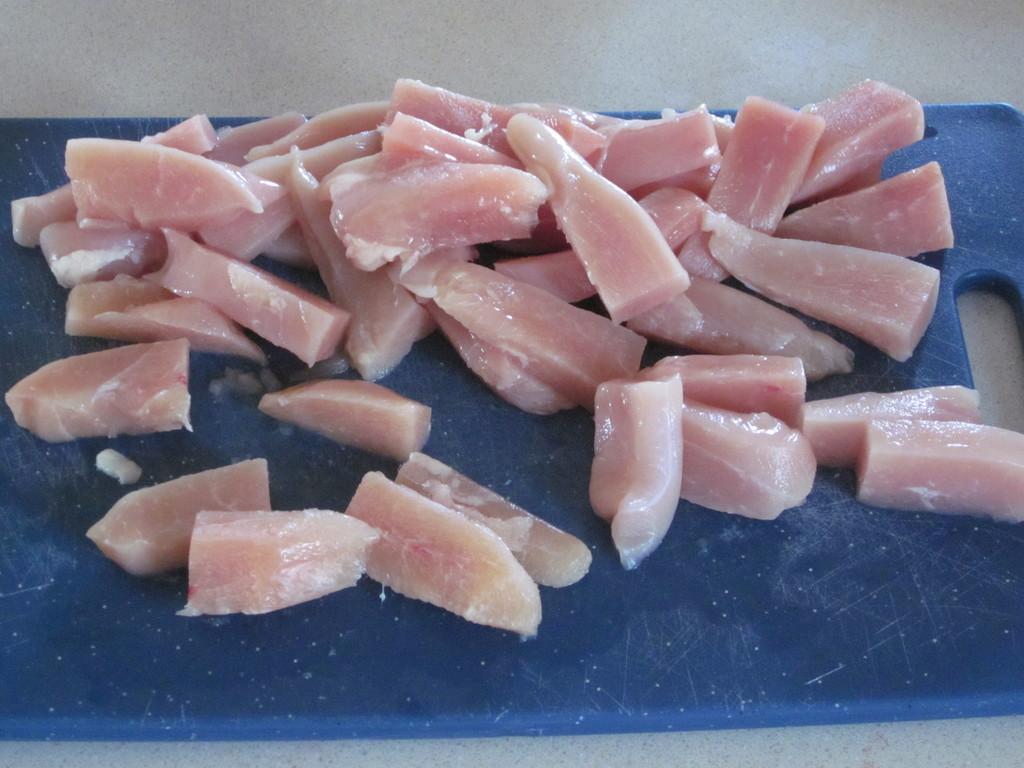In one or two sentences, can you explain what this image depicts? In this picture we can see a cutting board on the surface with meat pieces on it. 